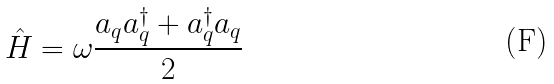Convert formula to latex. <formula><loc_0><loc_0><loc_500><loc_500>\hat { H } = \omega \frac { a _ { q } a _ { q } ^ { \dag } + a _ { q } ^ { \dag } a _ { q } } { 2 }</formula> 